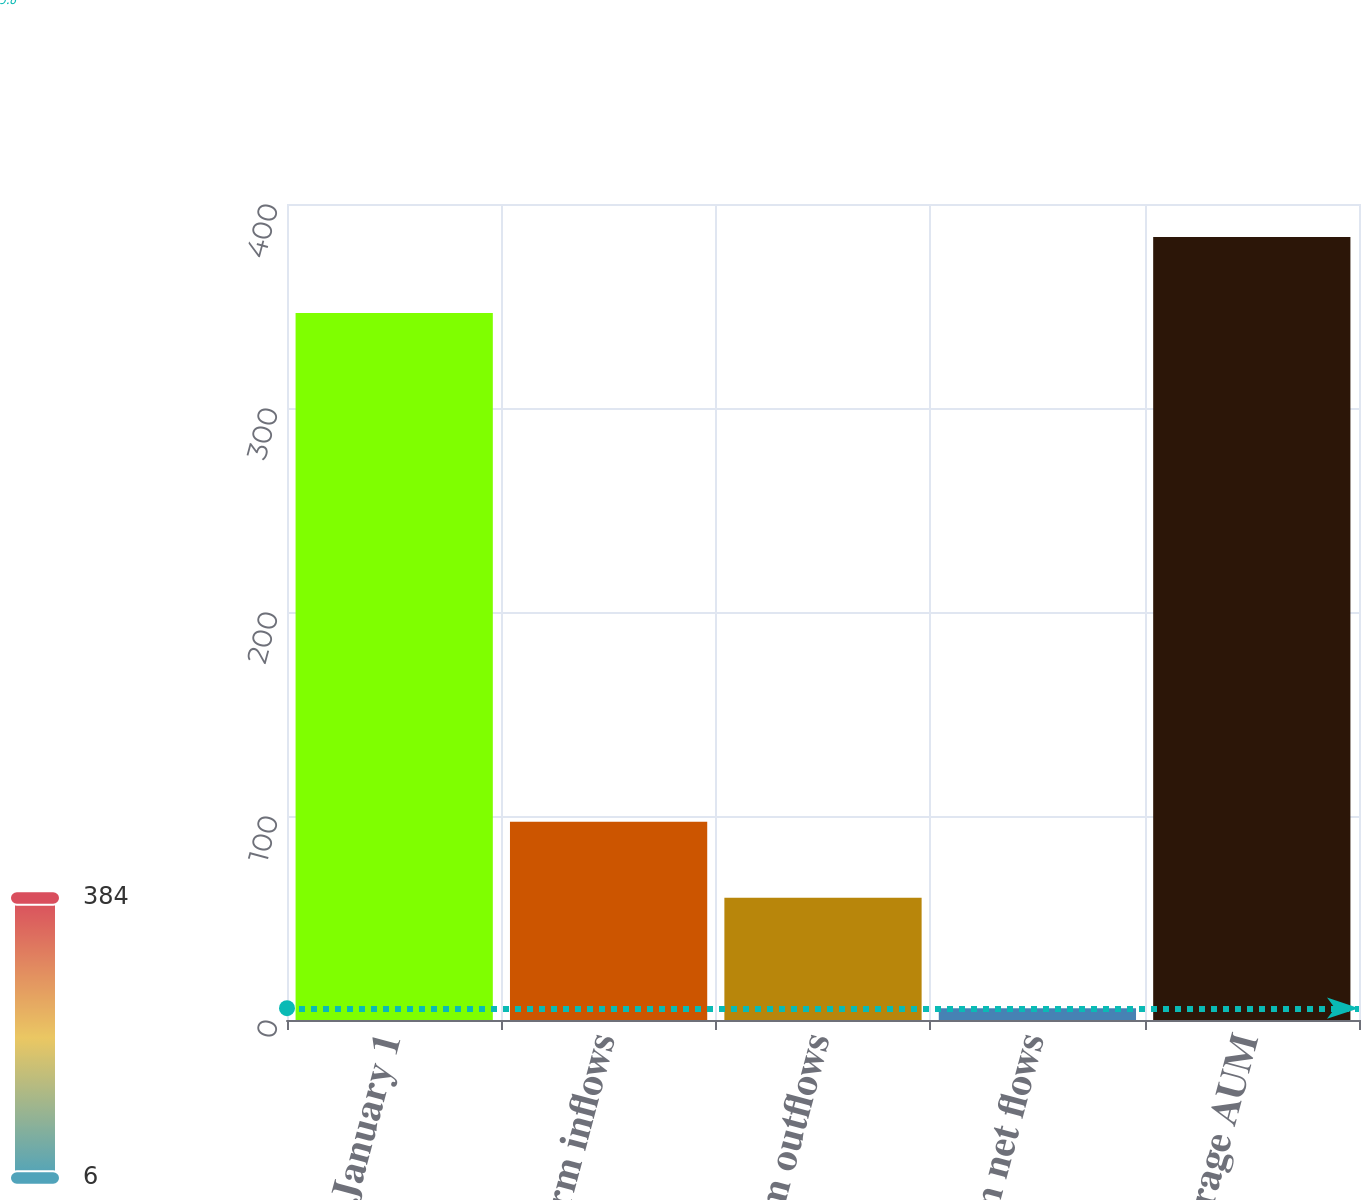Convert chart to OTSL. <chart><loc_0><loc_0><loc_500><loc_500><bar_chart><fcel>January 1<fcel>Long-term inflows<fcel>Long-term outflows<fcel>Long-term net flows<fcel>Average AUM<nl><fcel>346.6<fcel>97.14<fcel>59.9<fcel>5.8<fcel>383.84<nl></chart> 